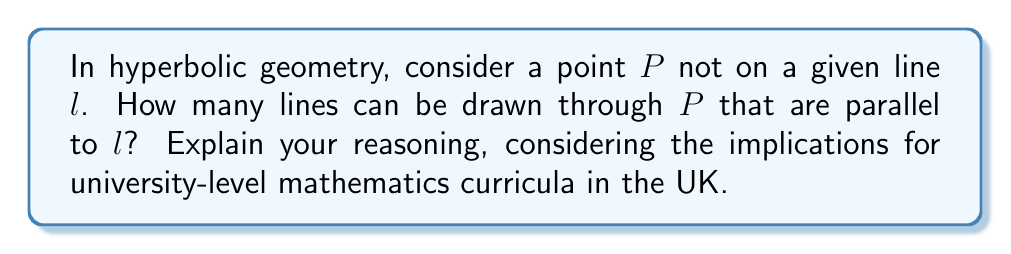Can you answer this question? To answer this question, let's consider the key properties of hyperbolic geometry:

1) In hyperbolic geometry, the parallel postulate does not hold. This means that through a point not on a given line, there can be more than one line parallel to the given line.

2) Let's visualize this using the Poincaré disk model of hyperbolic geometry:

[asy]
import geometry;

unitcircle();
pair A = (0.5,0);
pair B = (-0.5,0);
pair P = (0,0.6);

draw(A--B);
draw(P--(1,0.6), blue);
draw(P--(-1,0.6), blue);
draw(P--(0.866,-0.5), blue);
draw(P--(-0.866,-0.5), blue);

dot("P", P, N);
dot("A", A, S);
dot("B", B, S);
label("$l$", (0,-0.1), S);
[/asy]

3) In this model, the line $l$ is represented by the chord AB, and P is a point not on $l$.

4) The blue lines represent some of the infinitely many lines through P that do not intersect $l$ within the disk.

5) In hyperbolic geometry, these blue lines are considered parallel to $l$.

6) In fact, there are infinitely many such lines. They form a "pencil" of lines through P, bounded by two limiting parallel lines (the outermost blue lines in our diagram).

7) This concept of infinitely many parallels is a fundamental difference between Euclidean and hyperbolic geometry.

For UK university curricula, understanding this concept is crucial for students pursuing advanced mathematics, especially those interested in non-Euclidean geometries or theoretical physics where hyperbolic spaces play a role.
Answer: Infinitely many 